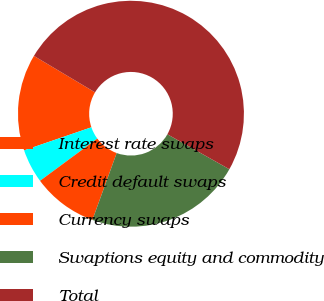Convert chart. <chart><loc_0><loc_0><loc_500><loc_500><pie_chart><fcel>Interest rate swaps<fcel>Credit default swaps<fcel>Currency swaps<fcel>Swaptions equity and commodity<fcel>Total<nl><fcel>13.81%<fcel>4.86%<fcel>9.34%<fcel>22.37%<fcel>49.61%<nl></chart> 